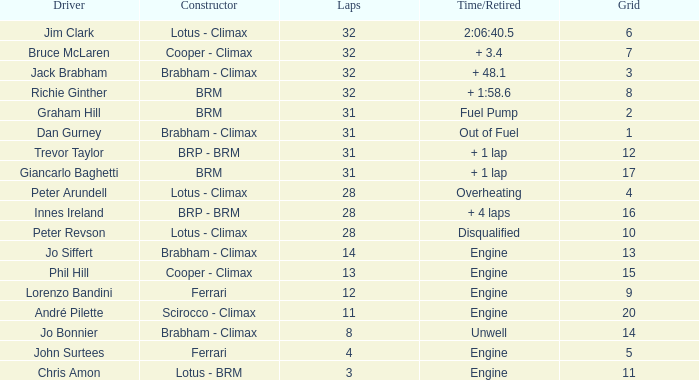What is the average grid for jack brabham going over 32 laps? None. 